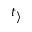Convert formula to latex. <formula><loc_0><loc_0><loc_500><loc_500>t _ { \rangle }</formula> 